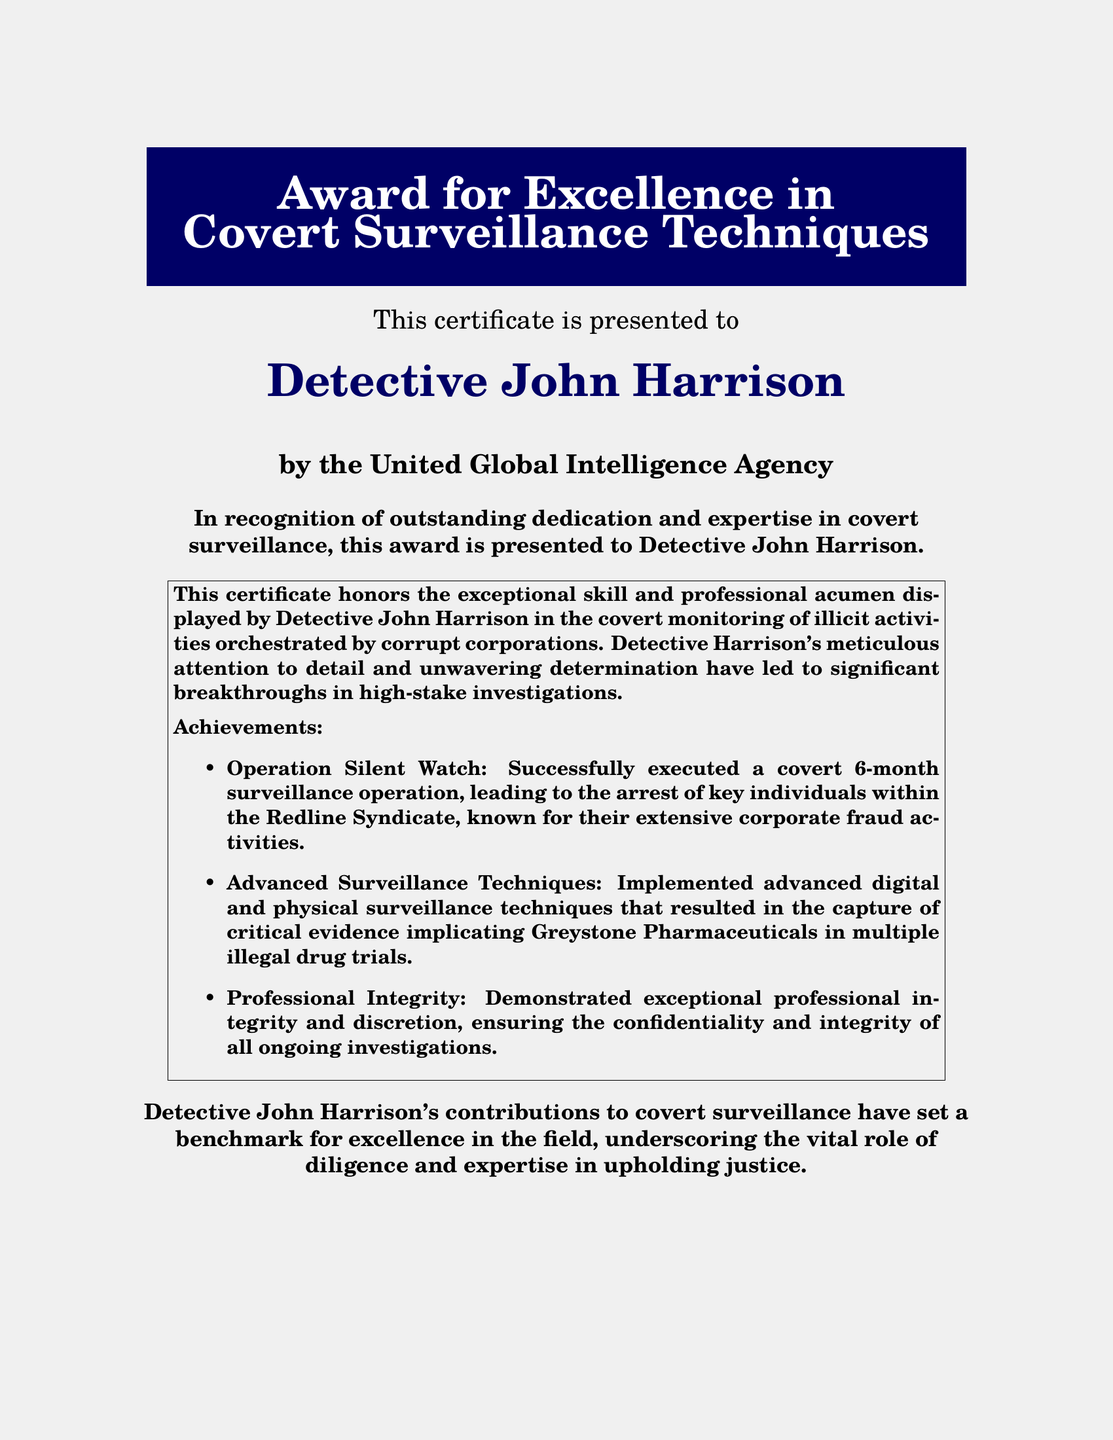What is the name of the award? The award is titled "Award for Excellence in Covert Surveillance Techniques," which is prominently displayed at the top of the document.
Answer: Award for Excellence in Covert Surveillance Techniques Who is the recipient of the award? The certificate is presented to Detective John Harrison, who is specified in a prominent section of the document.
Answer: Detective John Harrison Which organization issued the certificate? The document states that the award is presented by the United Global Intelligence Agency, which is indicated below the recipient's name.
Answer: United Global Intelligence Agency What is the date on which the award was given? The date of the award is included towards the bottom of the document as "October 20, 2023."
Answer: October 20, 2023 What operation led to the arrest of key individuals in the document? The document mentions "Operation Silent Watch" as the specific operation that resulted in arrests related to corporate fraud activities.
Answer: Operation Silent Watch What advanced technology did Detective Harrison implement? The certificate notes that advanced digital and physical surveillance techniques were implemented, which are referenced as part of the achievements.
Answer: Advanced digital and physical surveillance techniques What significant quality is highlighted about Detective Harrison's conduct? The document highlights "Professional Integrity" as a key quality displayed by Detective Harrison throughout the investigations.
Answer: Professional Integrity What has Detective Harrison's work set in the field of covert surveillance? The document claims that his contributions have set a benchmark for excellence, indicating the impact of his work in the field of covert surveillance.
Answer: Benchmark for excellence 